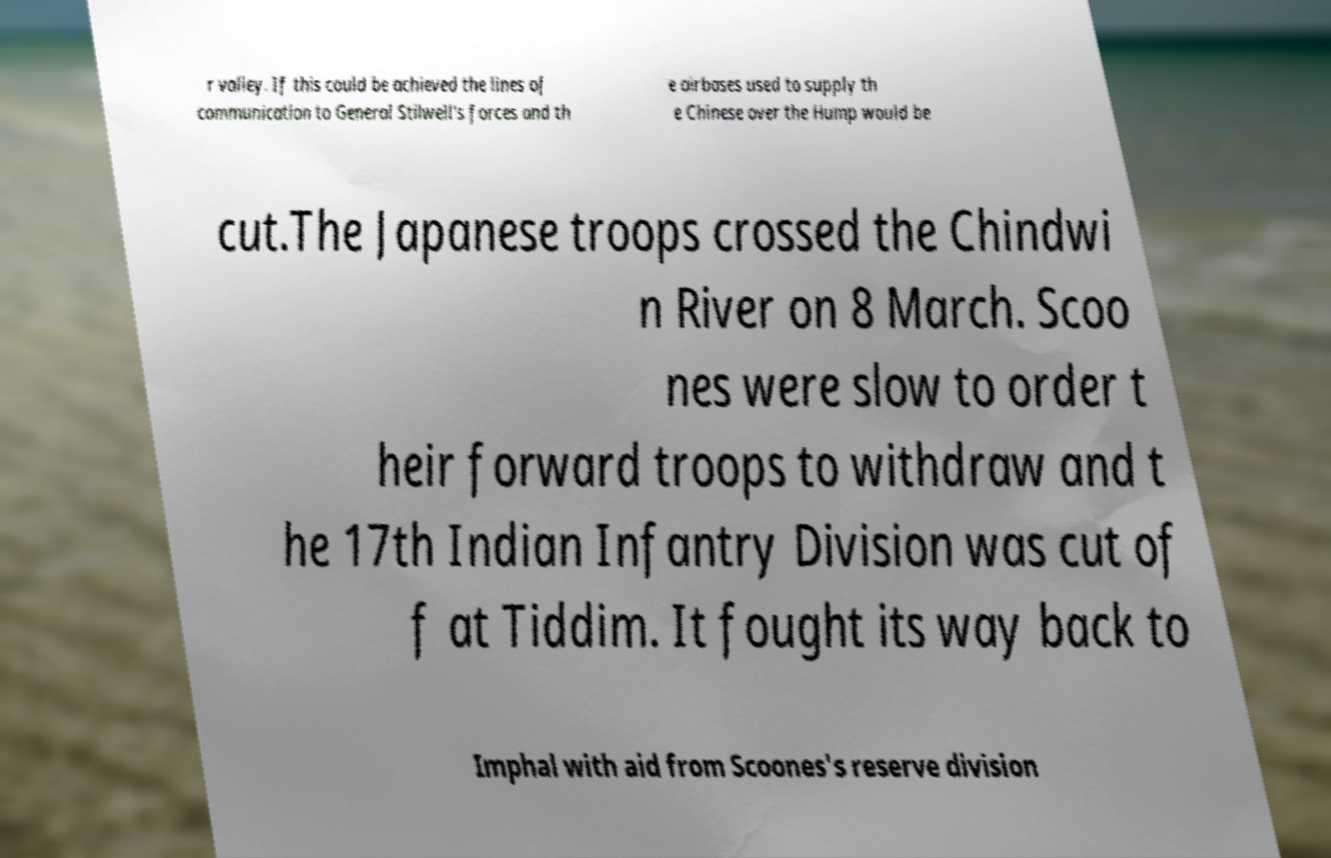What messages or text are displayed in this image? I need them in a readable, typed format. r valley. If this could be achieved the lines of communication to General Stilwell's forces and th e airbases used to supply th e Chinese over the Hump would be cut.The Japanese troops crossed the Chindwi n River on 8 March. Scoo nes were slow to order t heir forward troops to withdraw and t he 17th Indian Infantry Division was cut of f at Tiddim. It fought its way back to Imphal with aid from Scoones's reserve division 